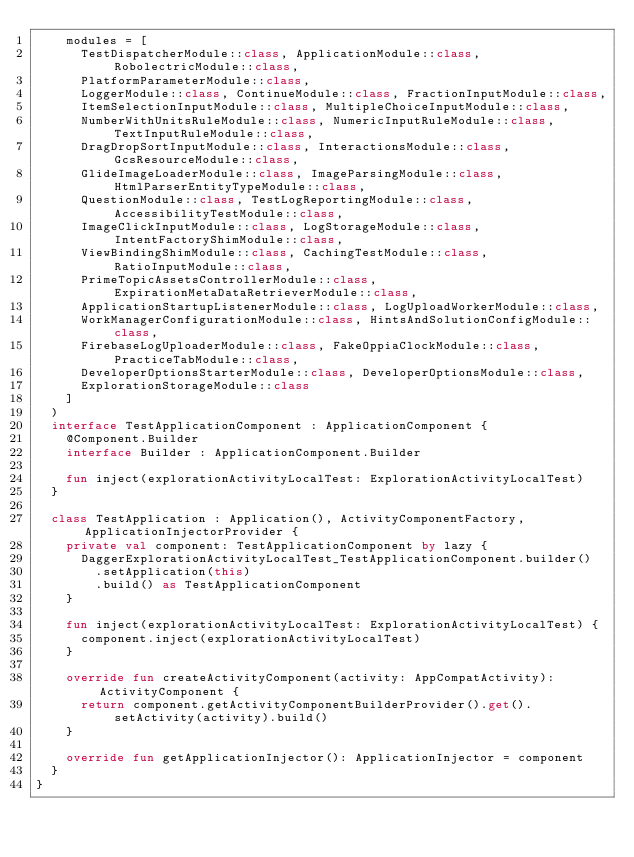<code> <loc_0><loc_0><loc_500><loc_500><_Kotlin_>    modules = [
      TestDispatcherModule::class, ApplicationModule::class, RobolectricModule::class,
      PlatformParameterModule::class,
      LoggerModule::class, ContinueModule::class, FractionInputModule::class,
      ItemSelectionInputModule::class, MultipleChoiceInputModule::class,
      NumberWithUnitsRuleModule::class, NumericInputRuleModule::class, TextInputRuleModule::class,
      DragDropSortInputModule::class, InteractionsModule::class, GcsResourceModule::class,
      GlideImageLoaderModule::class, ImageParsingModule::class, HtmlParserEntityTypeModule::class,
      QuestionModule::class, TestLogReportingModule::class, AccessibilityTestModule::class,
      ImageClickInputModule::class, LogStorageModule::class, IntentFactoryShimModule::class,
      ViewBindingShimModule::class, CachingTestModule::class, RatioInputModule::class,
      PrimeTopicAssetsControllerModule::class, ExpirationMetaDataRetrieverModule::class,
      ApplicationStartupListenerModule::class, LogUploadWorkerModule::class,
      WorkManagerConfigurationModule::class, HintsAndSolutionConfigModule::class,
      FirebaseLogUploaderModule::class, FakeOppiaClockModule::class, PracticeTabModule::class,
      DeveloperOptionsStarterModule::class, DeveloperOptionsModule::class,
      ExplorationStorageModule::class
    ]
  )
  interface TestApplicationComponent : ApplicationComponent {
    @Component.Builder
    interface Builder : ApplicationComponent.Builder

    fun inject(explorationActivityLocalTest: ExplorationActivityLocalTest)
  }

  class TestApplication : Application(), ActivityComponentFactory, ApplicationInjectorProvider {
    private val component: TestApplicationComponent by lazy {
      DaggerExplorationActivityLocalTest_TestApplicationComponent.builder()
        .setApplication(this)
        .build() as TestApplicationComponent
    }

    fun inject(explorationActivityLocalTest: ExplorationActivityLocalTest) {
      component.inject(explorationActivityLocalTest)
    }

    override fun createActivityComponent(activity: AppCompatActivity): ActivityComponent {
      return component.getActivityComponentBuilderProvider().get().setActivity(activity).build()
    }

    override fun getApplicationInjector(): ApplicationInjector = component
  }
}
</code> 